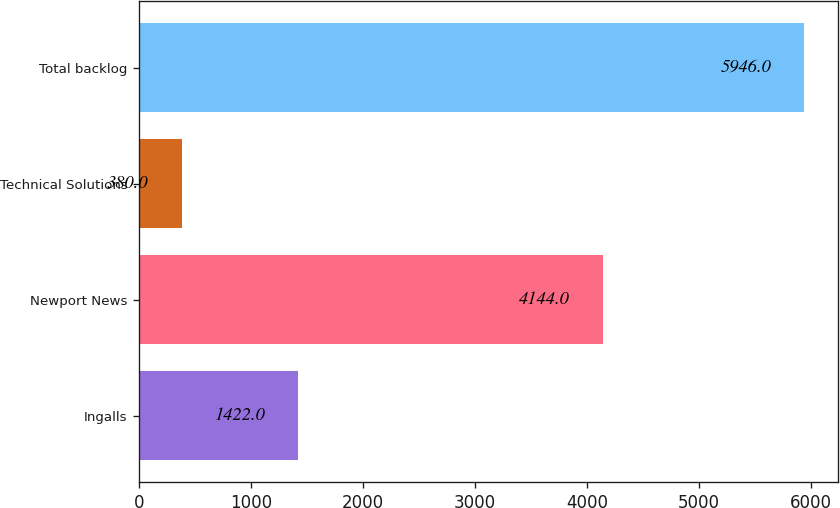Convert chart to OTSL. <chart><loc_0><loc_0><loc_500><loc_500><bar_chart><fcel>Ingalls<fcel>Newport News<fcel>Technical Solutions<fcel>Total backlog<nl><fcel>1422<fcel>4144<fcel>380<fcel>5946<nl></chart> 